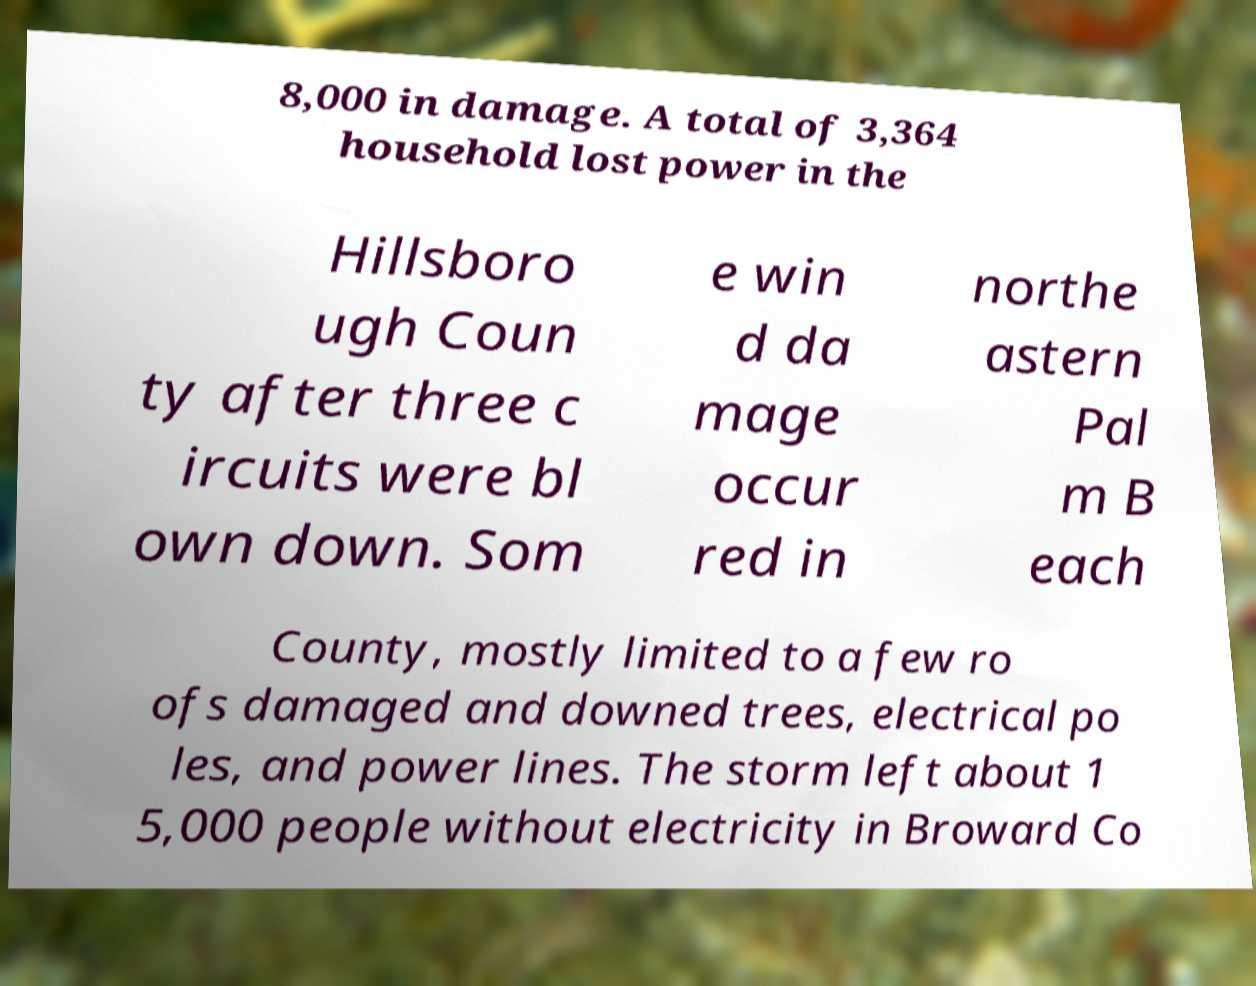For documentation purposes, I need the text within this image transcribed. Could you provide that? 8,000 in damage. A total of 3,364 household lost power in the Hillsboro ugh Coun ty after three c ircuits were bl own down. Som e win d da mage occur red in northe astern Pal m B each County, mostly limited to a few ro ofs damaged and downed trees, electrical po les, and power lines. The storm left about 1 5,000 people without electricity in Broward Co 